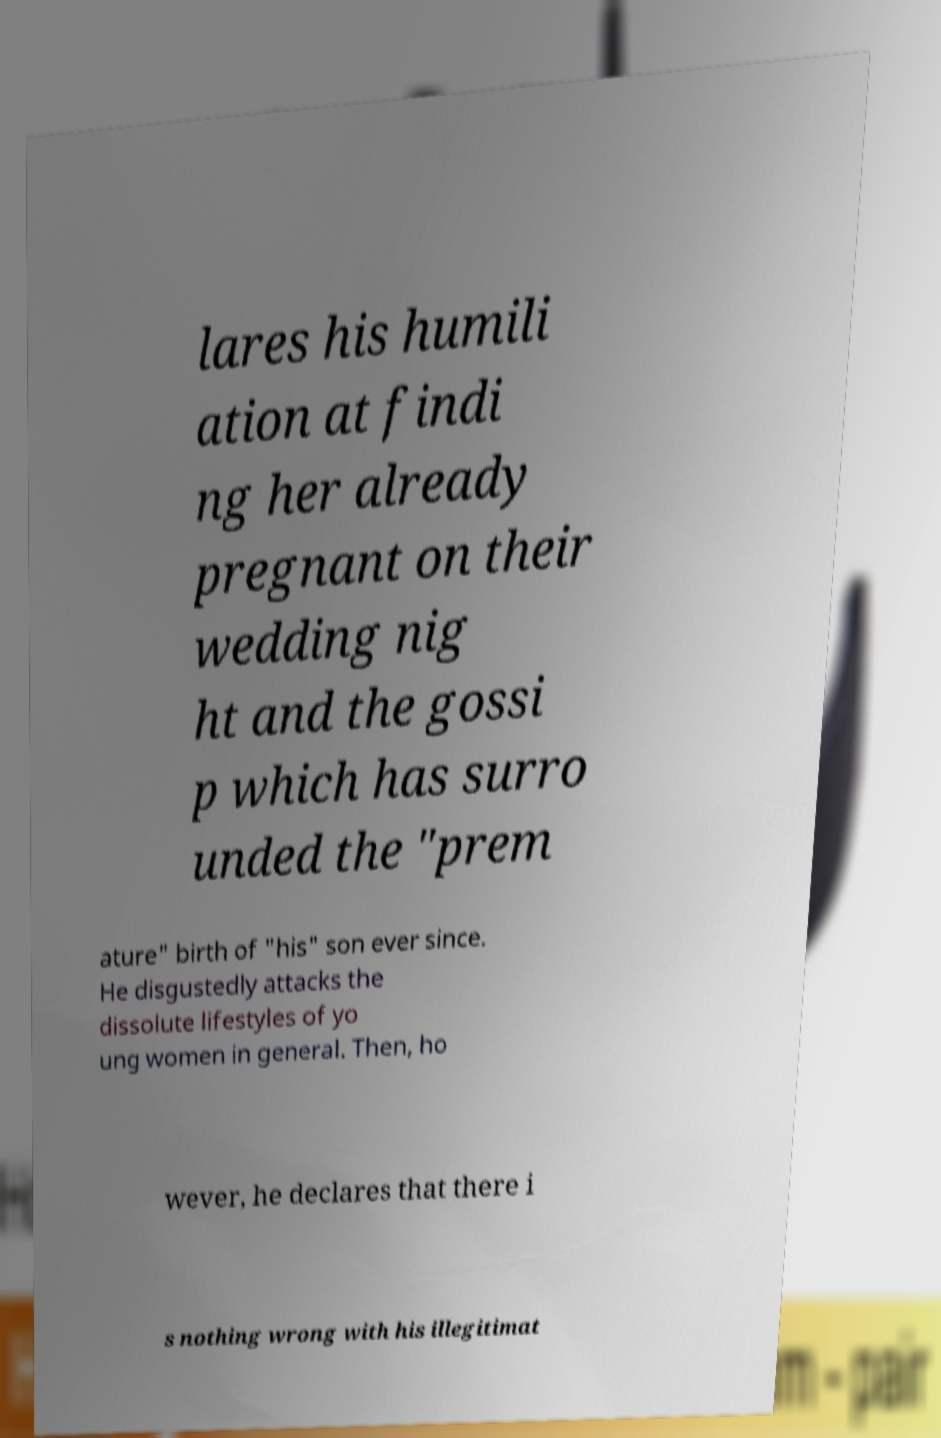I need the written content from this picture converted into text. Can you do that? lares his humili ation at findi ng her already pregnant on their wedding nig ht and the gossi p which has surro unded the "prem ature" birth of "his" son ever since. He disgustedly attacks the dissolute lifestyles of yo ung women in general. Then, ho wever, he declares that there i s nothing wrong with his illegitimat 